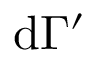Convert formula to latex. <formula><loc_0><loc_0><loc_500><loc_500>d \Gamma ^ { \prime }</formula> 